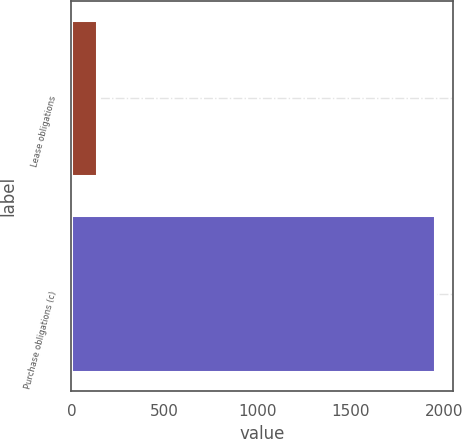Convert chart. <chart><loc_0><loc_0><loc_500><loc_500><bar_chart><fcel>Lease obligations<fcel>Purchase obligations (c)<nl><fcel>136<fcel>1953<nl></chart> 